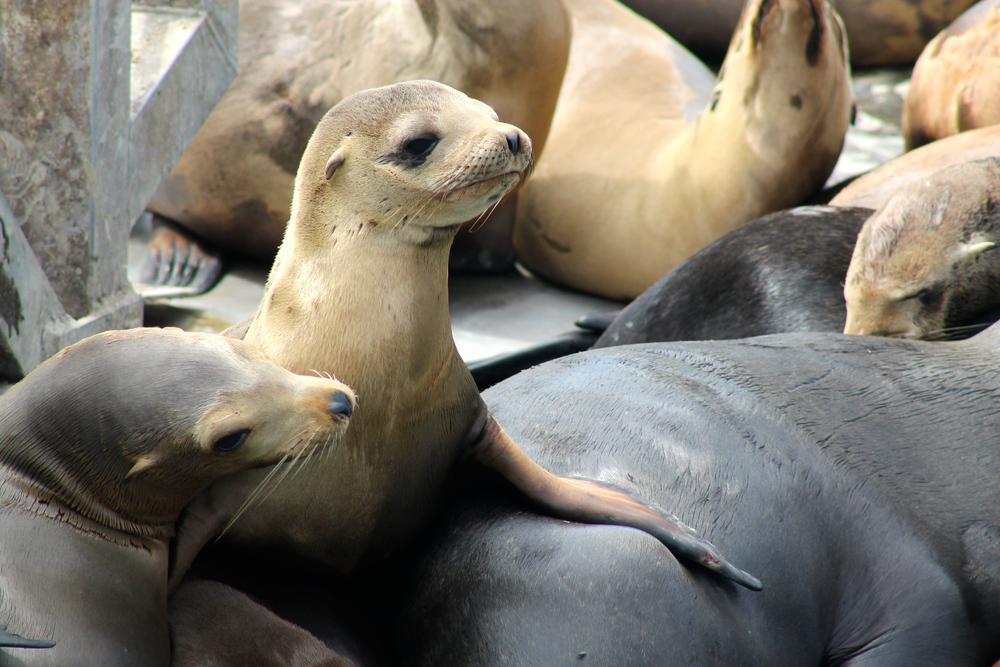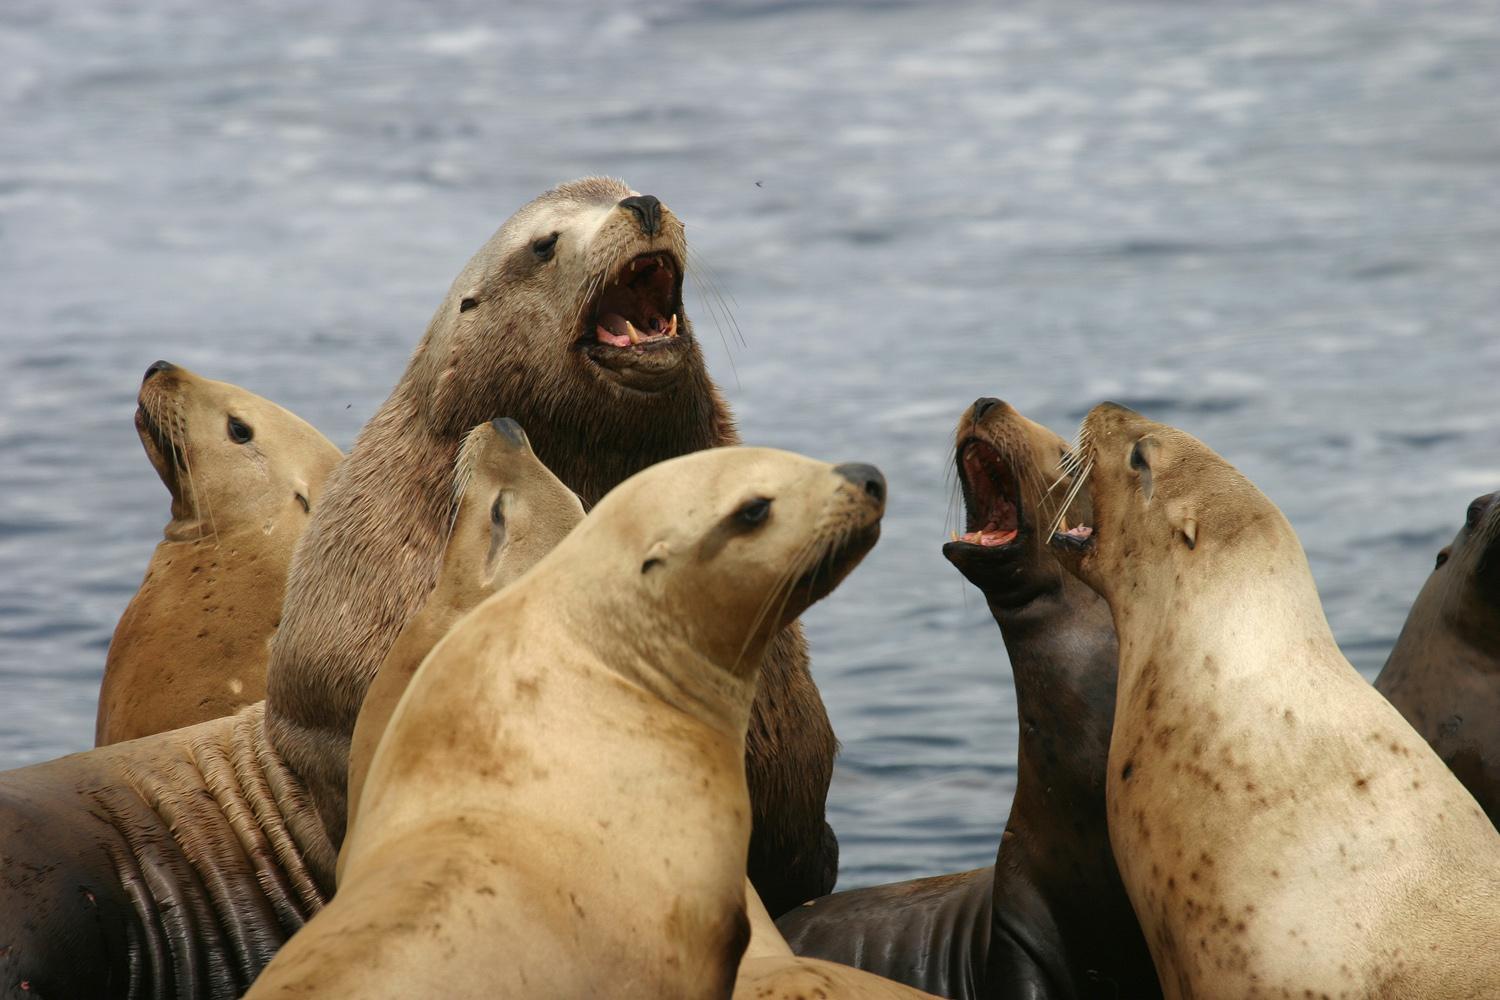The first image is the image on the left, the second image is the image on the right. For the images displayed, is the sentence "Right image shows multiple seals on a rock, and no seals have opened mouths." factually correct? Answer yes or no. No. The first image is the image on the left, the second image is the image on the right. Evaluate the accuracy of this statement regarding the images: "Two seals are sitting on a rock in the image on the left.". Is it true? Answer yes or no. No. 